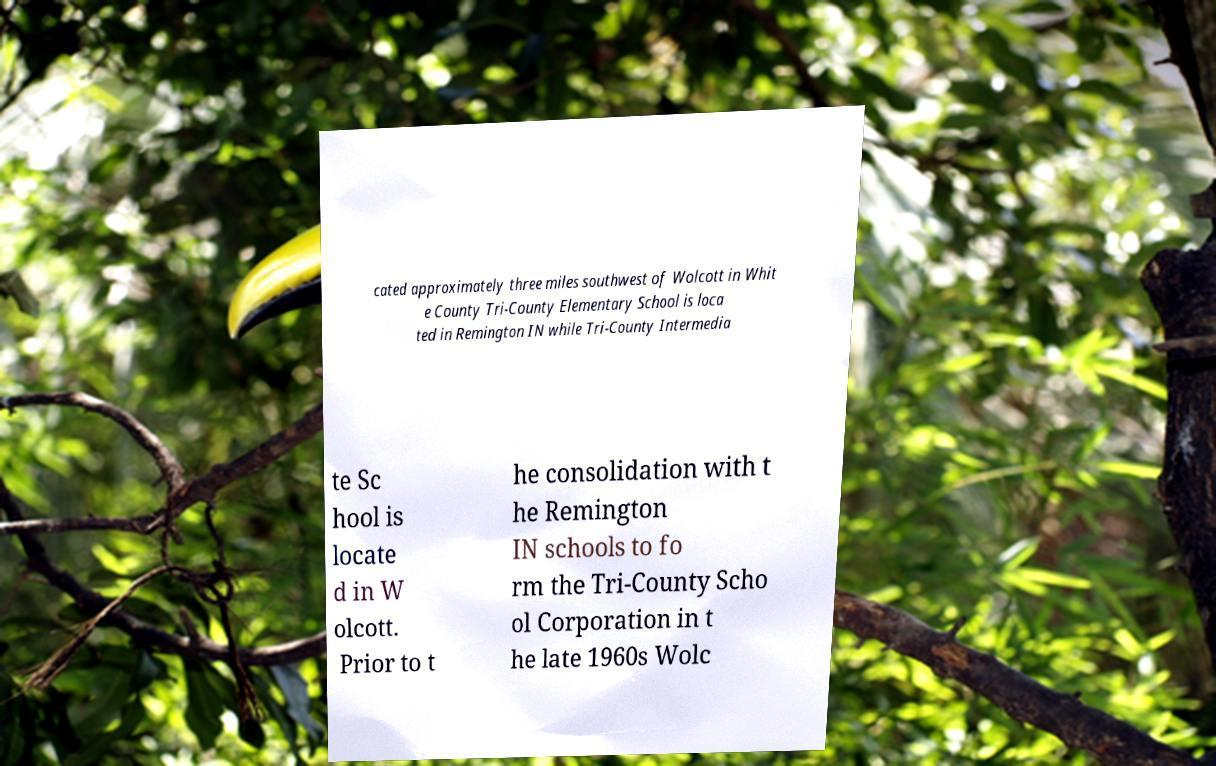Please read and relay the text visible in this image. What does it say? cated approximately three miles southwest of Wolcott in Whit e County Tri-County Elementary School is loca ted in Remington IN while Tri-County Intermedia te Sc hool is locate d in W olcott. Prior to t he consolidation with t he Remington IN schools to fo rm the Tri-County Scho ol Corporation in t he late 1960s Wolc 